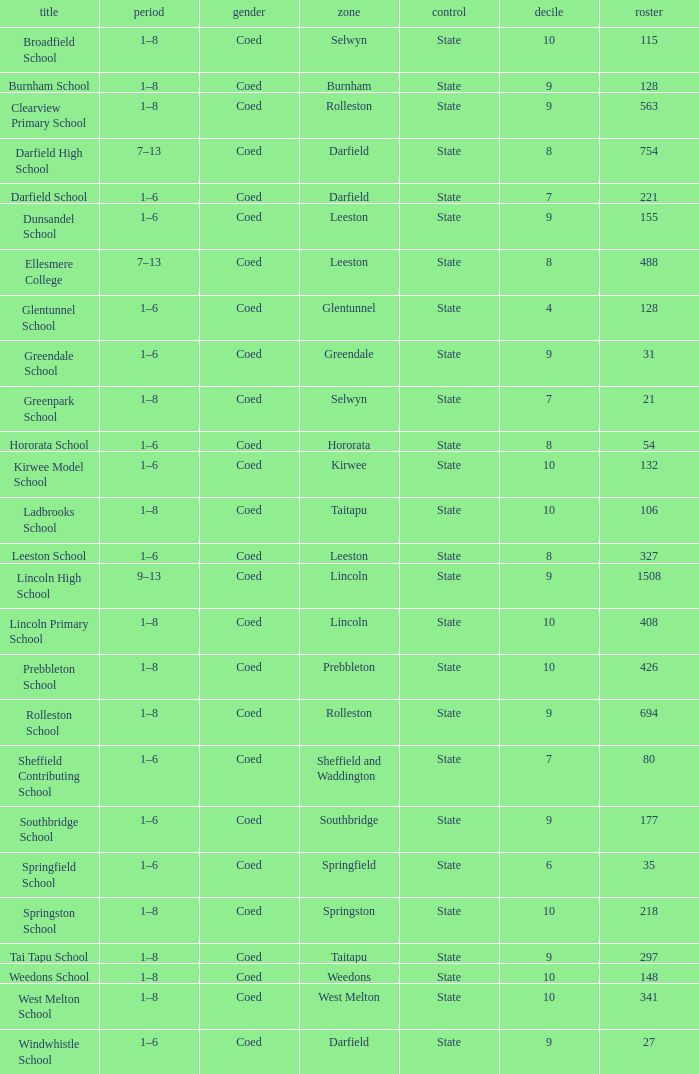What is the name with a Decile less than 10, and a Roll of 297? Tai Tapu School. 